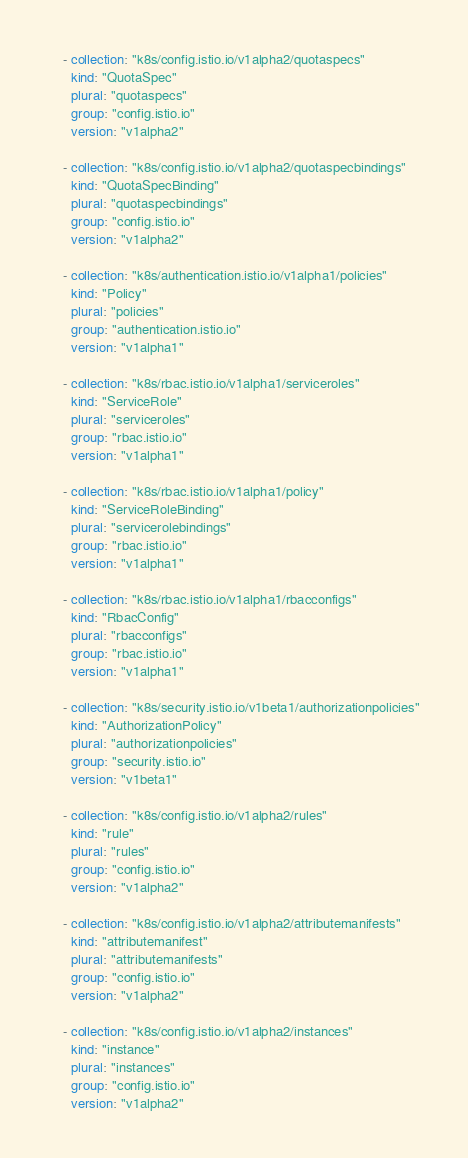Convert code to text. <code><loc_0><loc_0><loc_500><loc_500><_YAML_>
    - collection: "k8s/config.istio.io/v1alpha2/quotaspecs"
      kind: "QuotaSpec"
      plural: "quotaspecs"
      group: "config.istio.io"
      version: "v1alpha2"

    - collection: "k8s/config.istio.io/v1alpha2/quotaspecbindings"
      kind: "QuotaSpecBinding"
      plural: "quotaspecbindings"
      group: "config.istio.io"
      version: "v1alpha2"

    - collection: "k8s/authentication.istio.io/v1alpha1/policies"
      kind: "Policy"
      plural: "policies"
      group: "authentication.istio.io"
      version: "v1alpha1"

    - collection: "k8s/rbac.istio.io/v1alpha1/serviceroles"
      kind: "ServiceRole"
      plural: "serviceroles"
      group: "rbac.istio.io"
      version: "v1alpha1"

    - collection: "k8s/rbac.istio.io/v1alpha1/policy"
      kind: "ServiceRoleBinding"
      plural: "servicerolebindings"
      group: "rbac.istio.io"
      version: "v1alpha1"

    - collection: "k8s/rbac.istio.io/v1alpha1/rbacconfigs"
      kind: "RbacConfig"
      plural: "rbacconfigs"
      group: "rbac.istio.io"
      version: "v1alpha1"

    - collection: "k8s/security.istio.io/v1beta1/authorizationpolicies"
      kind: "AuthorizationPolicy"
      plural: "authorizationpolicies"
      group: "security.istio.io"
      version: "v1beta1"

    - collection: "k8s/config.istio.io/v1alpha2/rules"
      kind: "rule"
      plural: "rules"
      group: "config.istio.io"
      version: "v1alpha2"

    - collection: "k8s/config.istio.io/v1alpha2/attributemanifests"
      kind: "attributemanifest"
      plural: "attributemanifests"
      group: "config.istio.io"
      version: "v1alpha2"

    - collection: "k8s/config.istio.io/v1alpha2/instances"
      kind: "instance"
      plural: "instances"
      group: "config.istio.io"
      version: "v1alpha2"
</code> 